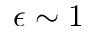<formula> <loc_0><loc_0><loc_500><loc_500>\epsilon \sim 1</formula> 